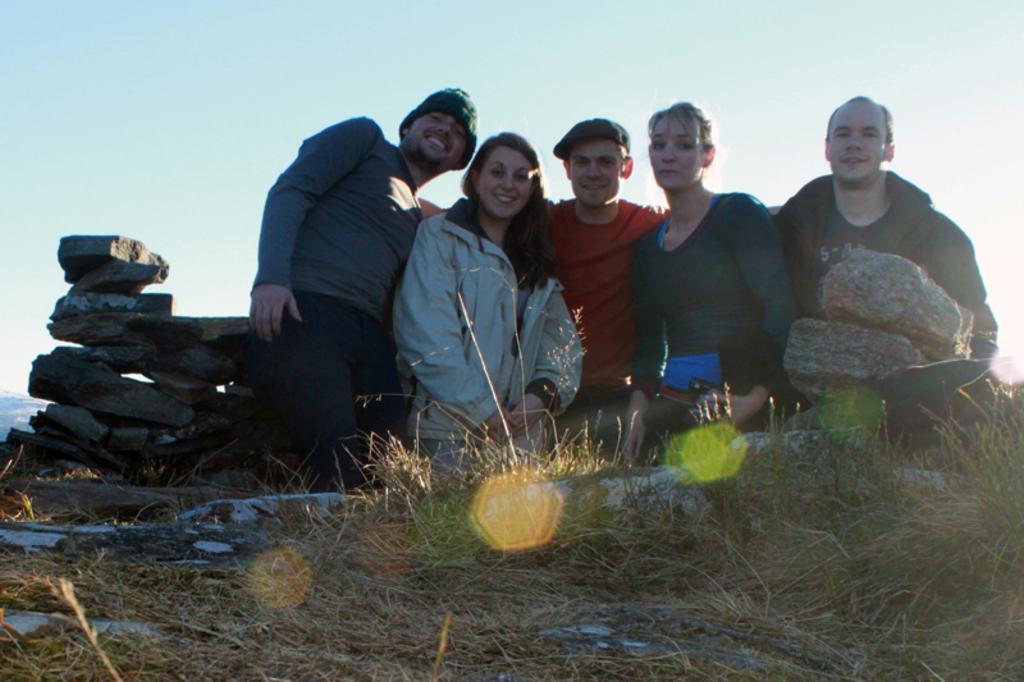How would you summarize this image in a sentence or two? In this image I can see few people are standing and wearing different color dresses. I can see a dry grass and few stone. The sky is in white and blue color. 